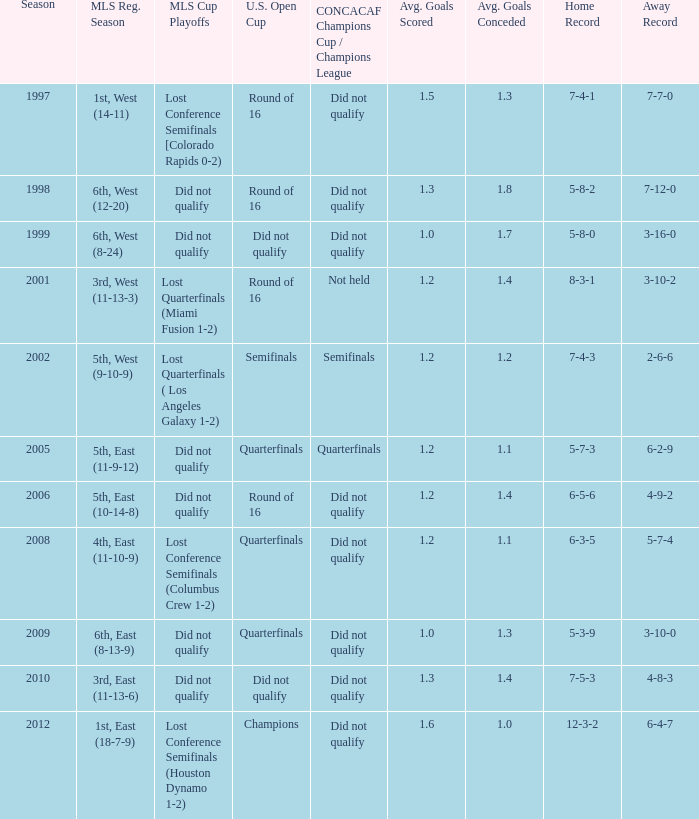When was the first season? 1997.0. 